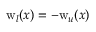Convert formula to latex. <formula><loc_0><loc_0><loc_500><loc_500>w _ { l } ( x ) = - w _ { u } ( x )</formula> 